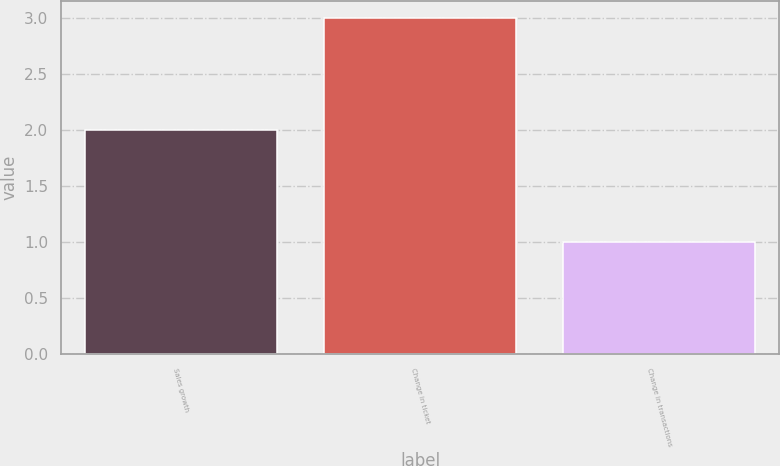Convert chart. <chart><loc_0><loc_0><loc_500><loc_500><bar_chart><fcel>Sales growth<fcel>Change in ticket<fcel>Change in transactions<nl><fcel>2<fcel>3<fcel>1<nl></chart> 